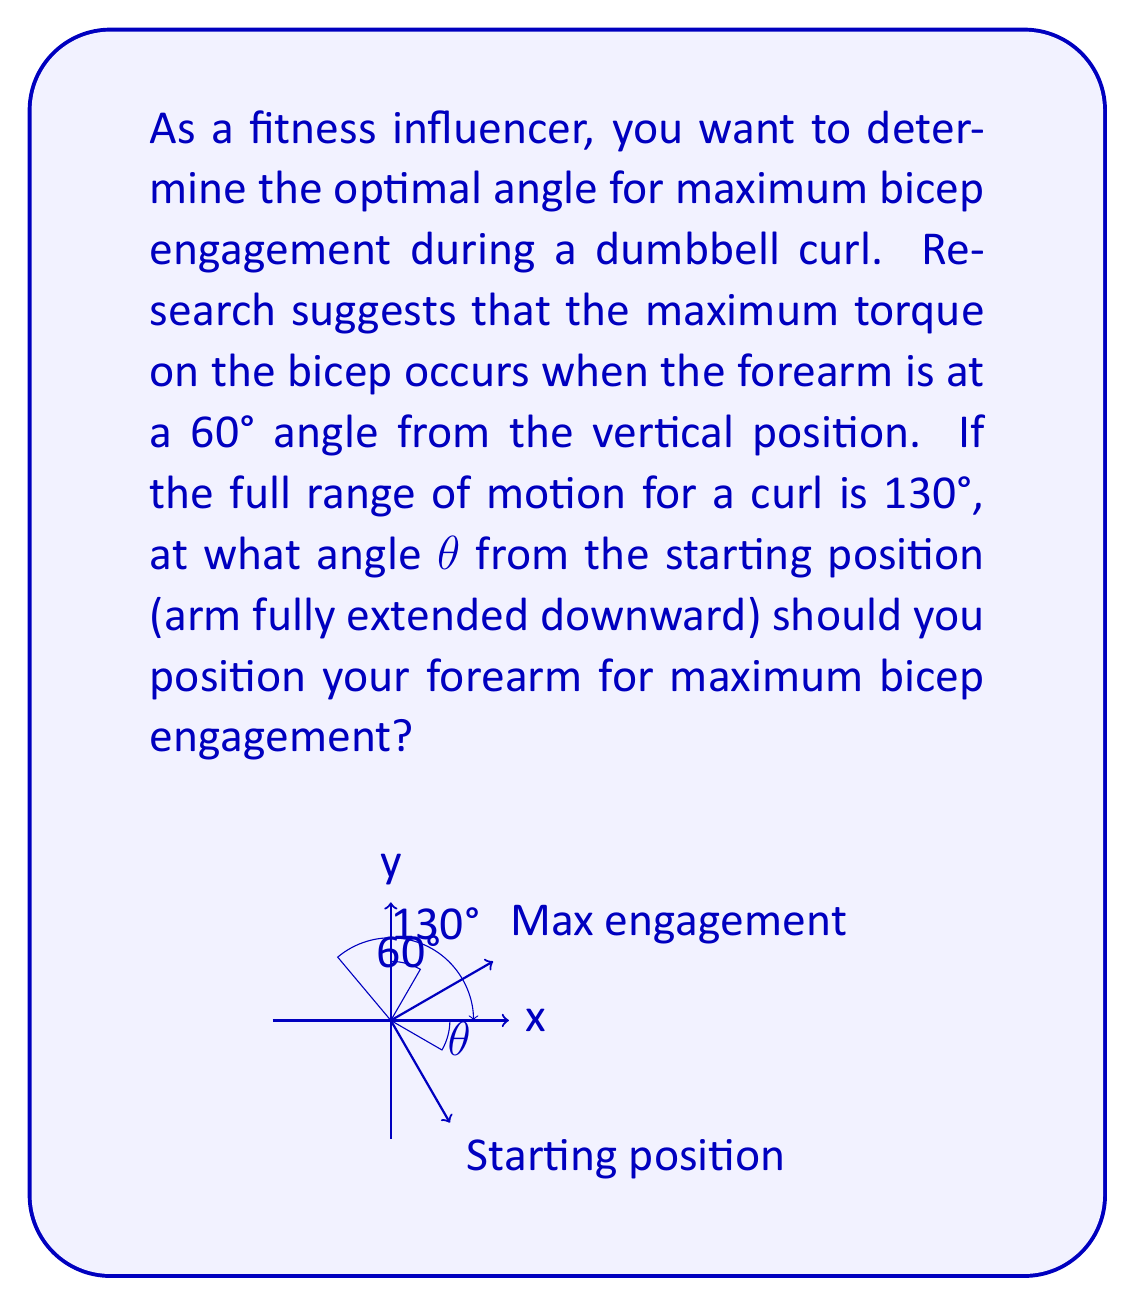Help me with this question. Let's approach this step-by-step:

1) The full range of motion is 130°, starting from the arm fully extended downward to the fully curled position.

2) The angle of maximum engagement is 60° from the vertical position, which is 90° from the starting position.

3) We need to find the angle θ from the starting position to the point of maximum engagement.

4) We can set up the equation:
   
   $$\theta + 60° = 90°$$

5) Solving for θ:
   
   $$\theta = 90° - 60° = 30°$$

6) To verify, we can check if this makes sense within the full range of motion:
   
   $$30° + (90° - 30°) = 90°$$
   $$30° + 60° = 90°$$

   This confirms that our solution fits within the 130° range of motion, as 90° < 130°.

Therefore, the forearm should be positioned at a 30° angle from the starting position for maximum bicep engagement during a dumbbell curl.
Answer: $\theta = 30°$ 